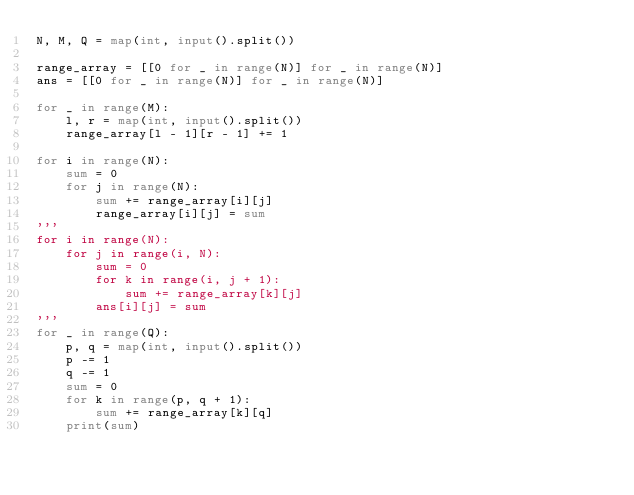Convert code to text. <code><loc_0><loc_0><loc_500><loc_500><_Python_>N, M, Q = map(int, input().split())

range_array = [[0 for _ in range(N)] for _ in range(N)]
ans = [[0 for _ in range(N)] for _ in range(N)]

for _ in range(M):
    l, r = map(int, input().split())
    range_array[l - 1][r - 1] += 1

for i in range(N):
    sum = 0
    for j in range(N):
        sum += range_array[i][j]
        range_array[i][j] = sum
'''
for i in range(N):
    for j in range(i, N):
        sum = 0
        for k in range(i, j + 1):
            sum += range_array[k][j]
        ans[i][j] = sum
'''
for _ in range(Q):
    p, q = map(int, input().split())
    p -= 1
    q -= 1
    sum = 0
    for k in range(p, q + 1):
        sum += range_array[k][q]
    print(sum)
</code> 